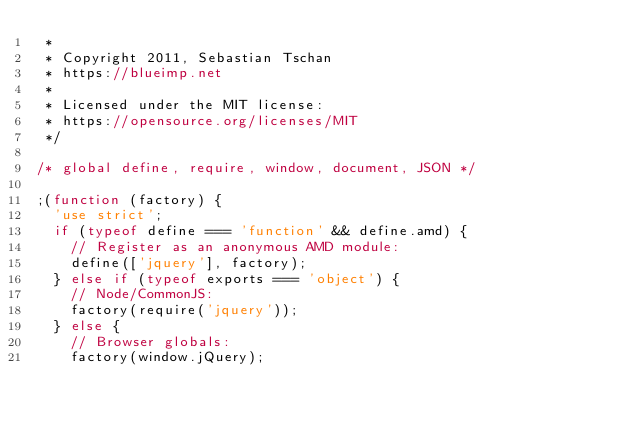<code> <loc_0><loc_0><loc_500><loc_500><_JavaScript_> *
 * Copyright 2011, Sebastian Tschan
 * https://blueimp.net
 *
 * Licensed under the MIT license:
 * https://opensource.org/licenses/MIT
 */

/* global define, require, window, document, JSON */

;(function (factory) {
	'use strict';
	if (typeof define === 'function' && define.amd) {
		// Register as an anonymous AMD module:
		define(['jquery'], factory);
	} else if (typeof exports === 'object') {
		// Node/CommonJS:
		factory(require('jquery'));
	} else {
		// Browser globals:
		factory(window.jQuery);</code> 